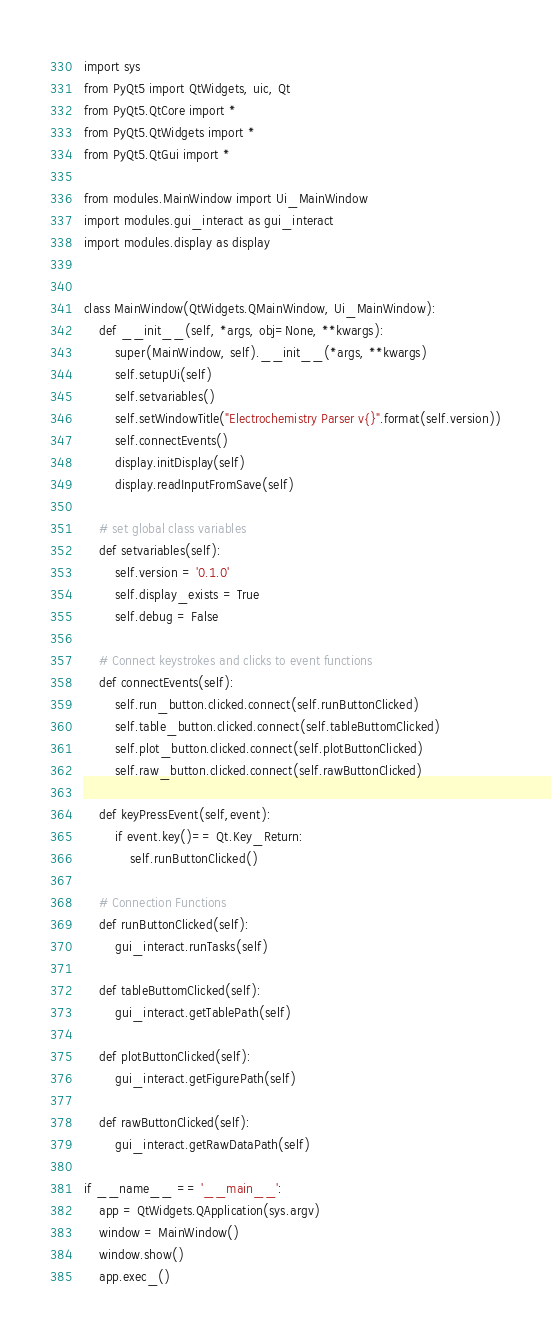<code> <loc_0><loc_0><loc_500><loc_500><_Python_>import sys
from PyQt5 import QtWidgets, uic, Qt
from PyQt5.QtCore import *
from PyQt5.QtWidgets import *
from PyQt5.QtGui import *

from modules.MainWindow import Ui_MainWindow
import modules.gui_interact as gui_interact
import modules.display as display


class MainWindow(QtWidgets.QMainWindow, Ui_MainWindow):
    def __init__(self, *args, obj=None, **kwargs):
        super(MainWindow, self).__init__(*args, **kwargs)
        self.setupUi(self)
        self.setvariables()
        self.setWindowTitle("Electrochemistry Parser v{}".format(self.version))
        self.connectEvents()
        display.initDisplay(self)
        display.readInputFromSave(self)

    # set global class variables
    def setvariables(self):
        self.version = '0.1.0'
        self.display_exists = True
        self.debug = False

    # Connect keystrokes and clicks to event functions
    def connectEvents(self):
        self.run_button.clicked.connect(self.runButtonClicked)
        self.table_button.clicked.connect(self.tableButtomClicked)
        self.plot_button.clicked.connect(self.plotButtonClicked)
        self.raw_button.clicked.connect(self.rawButtonClicked)

    def keyPressEvent(self,event): 
        if event.key()== Qt.Key_Return: 
            self.runButtonClicked()

    # Connection Functions 
    def runButtonClicked(self):
        gui_interact.runTasks(self)
    
    def tableButtomClicked(self):
        gui_interact.getTablePath(self)

    def plotButtonClicked(self):
        gui_interact.getFigurePath(self)
    
    def rawButtonClicked(self):
        gui_interact.getRawDataPath(self)
        
if __name__ == '__main__':
    app = QtWidgets.QApplication(sys.argv)
    window = MainWindow()
    window.show()
    app.exec_()</code> 